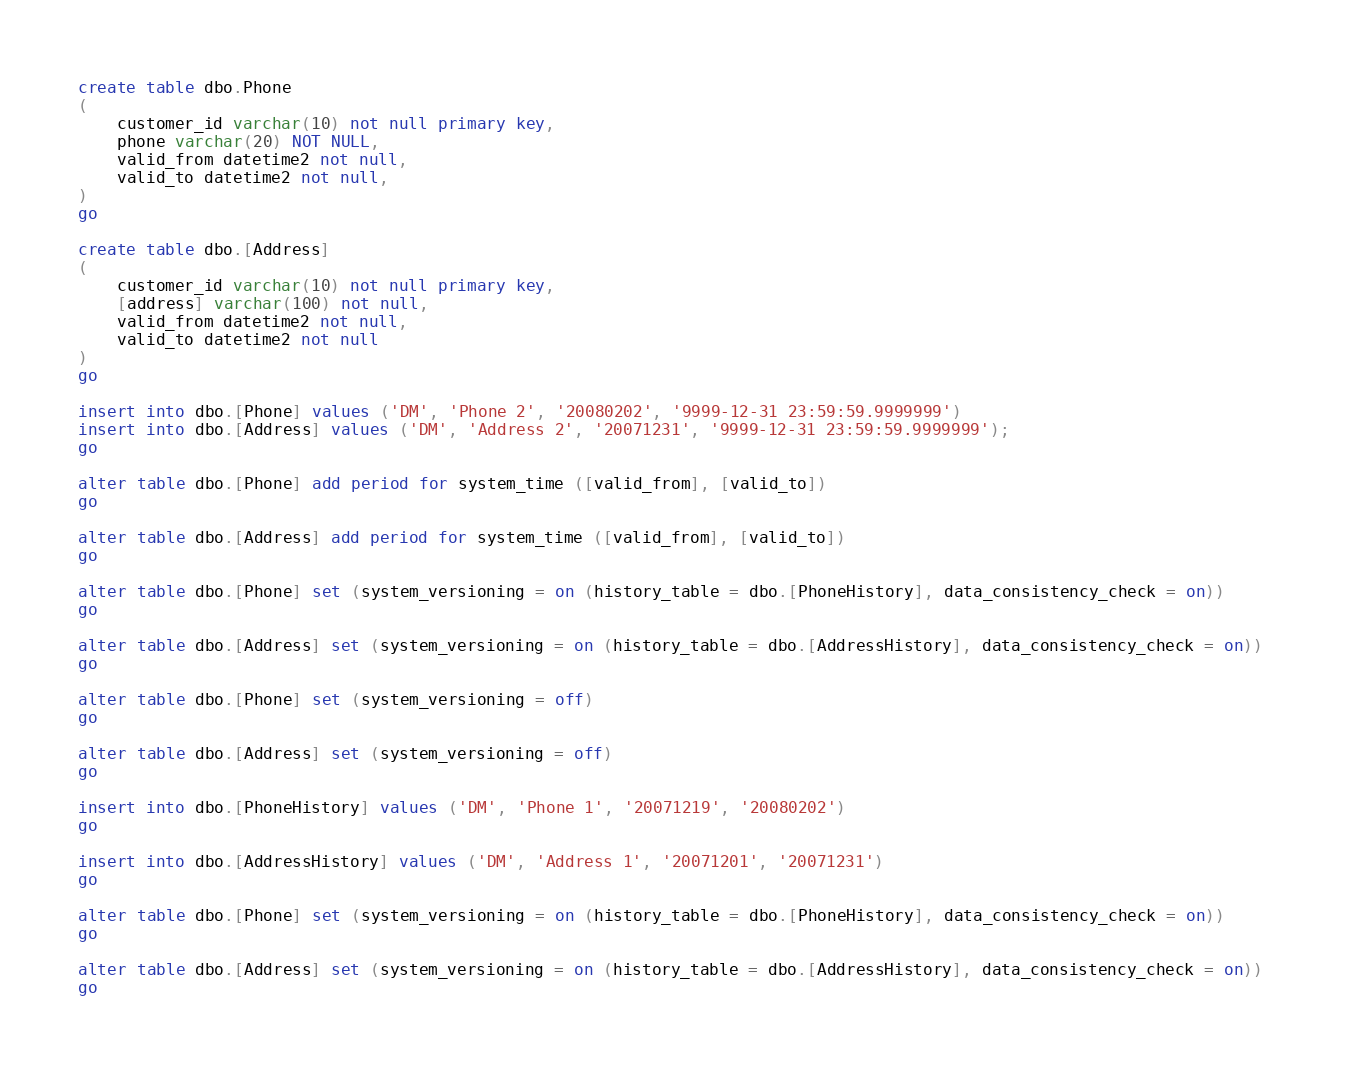Convert code to text. <code><loc_0><loc_0><loc_500><loc_500><_SQL_>create table dbo.Phone
(
	customer_id varchar(10) not null primary key,
	phone varchar(20) NOT NULL,
	valid_from datetime2 not null,  
	valid_to datetime2 not null,  
)
go

create table dbo.[Address]
(
	customer_id varchar(10) not null primary key,
	[address] varchar(100) not null,
	valid_from datetime2 not null,  
	valid_to datetime2 not null
) 
go

insert into dbo.[Phone] values ('DM', 'Phone 2', '20080202', '9999-12-31 23:59:59.9999999') 
insert into dbo.[Address] values ('DM', 'Address 2', '20071231', '9999-12-31 23:59:59.9999999');
go

alter table dbo.[Phone] add period for system_time ([valid_from], [valid_to]) 
go

alter table dbo.[Address] add period for system_time ([valid_from], [valid_to]) 
go

alter table dbo.[Phone] set (system_versioning = on (history_table = dbo.[PhoneHistory], data_consistency_check = on))   
go 

alter table dbo.[Address] set (system_versioning = on (history_table = dbo.[AddressHistory], data_consistency_check = on))   
go 

alter table dbo.[Phone] set (system_versioning = off)   
go 

alter table dbo.[Address] set (system_versioning = off)   
go 

insert into dbo.[PhoneHistory] values ('DM', 'Phone 1', '20071219', '20080202')
go

insert into dbo.[AddressHistory] values ('DM', 'Address 1', '20071201', '20071231')
go

alter table dbo.[Phone] set (system_versioning = on (history_table = dbo.[PhoneHistory], data_consistency_check = on))   
go 

alter table dbo.[Address] set (system_versioning = on (history_table = dbo.[AddressHistory], data_consistency_check = on))   
go 
</code> 